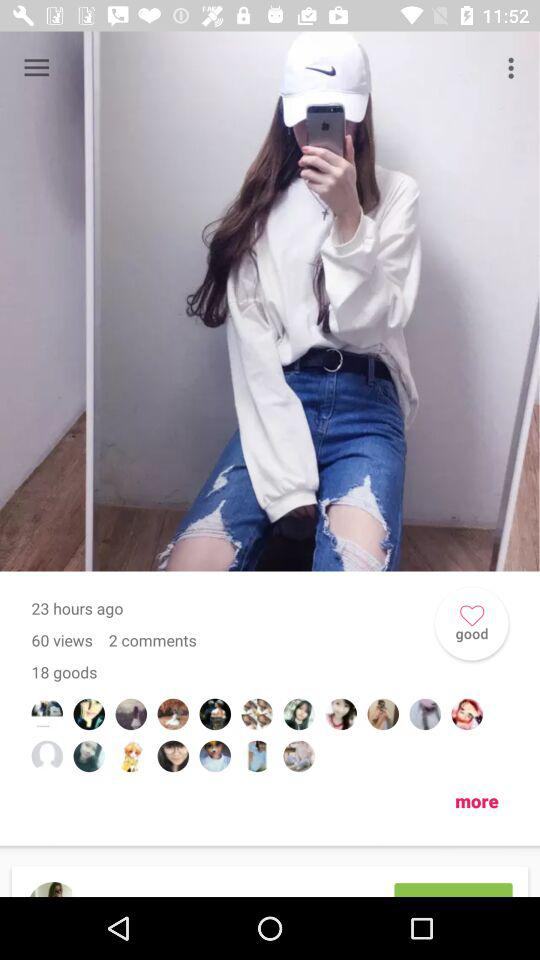How many views are there? There are 60 views. 